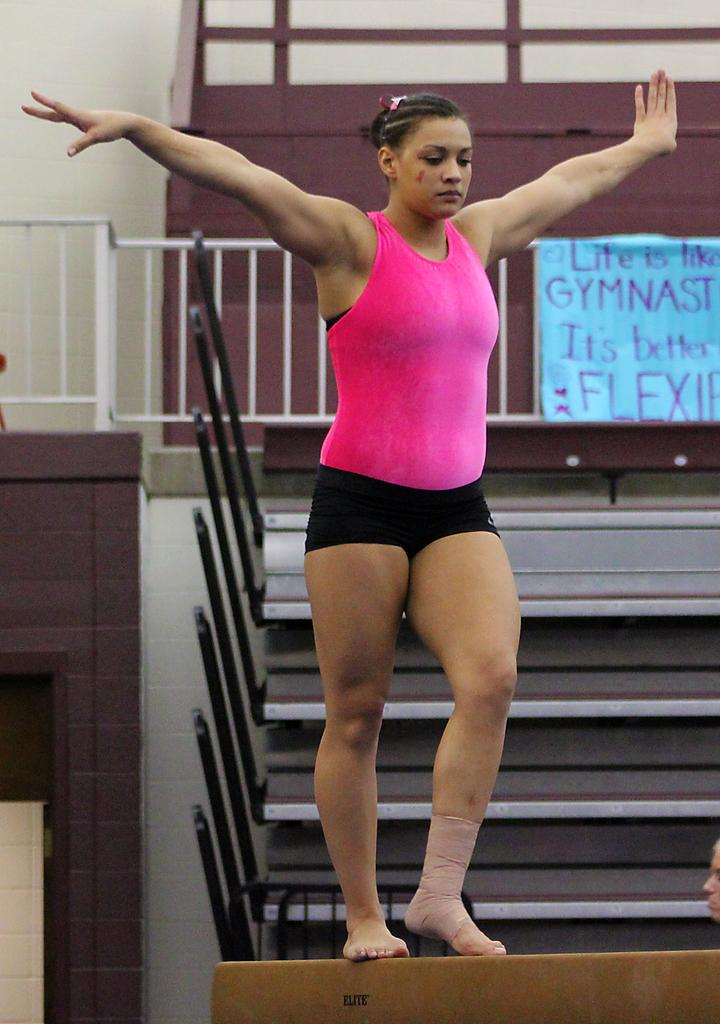What is the woman doing in the image? The woman is standing on a plank in the image. What can be seen in the background of the image? There is a poster, a fence, a wall, and some objects visible in the background of the image. How many rings are visible on the woman's fingers in the image? There is no information about rings on the woman's fingers in the image, so we cannot determine the number of rings. How many chairs are present in the image? There is no mention of chairs in the image, so we cannot determine the number of chairs. 